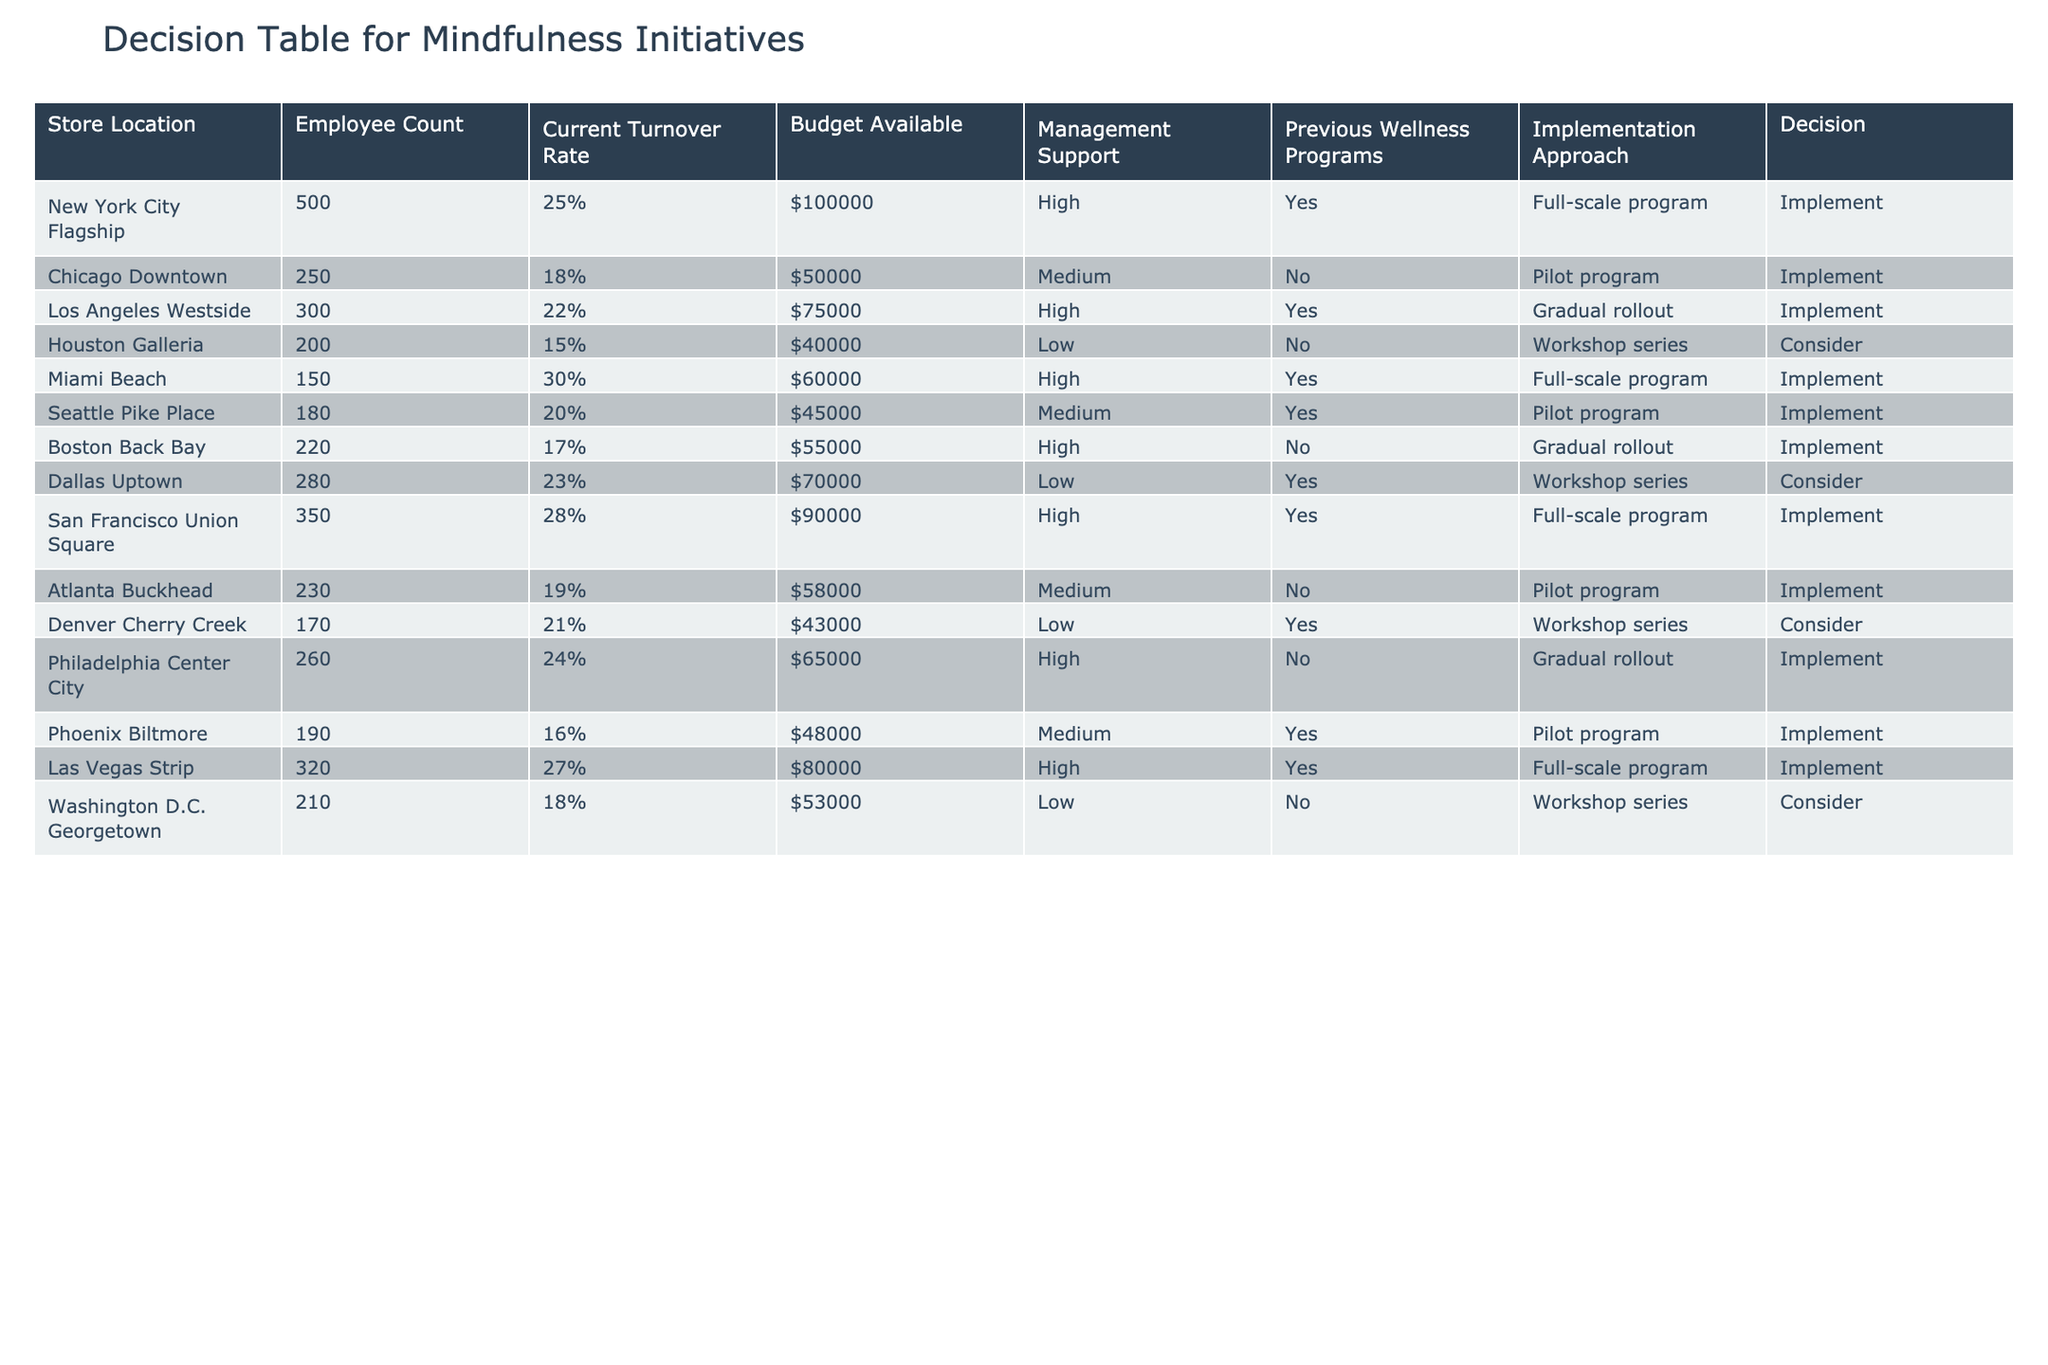What is the total employee count across all store locations? To find the total employee count, sum the Employee Count values from each row in the table: 500 + 250 + 300 + 200 + 150 + 180 + 220 + 280 + 350 + 230 + 170 + 260 + 190 + 320 + 210 = 3,060.
Answer: 3060 Which store location has the highest turnover rate? To find the highest turnover rate, compare the Current Turnover Rate values for each store. The maximum value is 30% from the Miami Beach location.
Answer: Miami Beach How many locations have implemented a full-scale program? Count the number of entries in the Decision column that state "Implement" and have "Full-scale program" in the Implementation Approach. These locations are New York City Flagship, Miami Beach, San Francisco Union Square, and Las Vegas Strip, giving a total of 4 locations.
Answer: 4 What is the average turnover rate of the stores with management support? First, identify the stores with High or Medium Management Support which are New York City Flagship, Los Angeles Westside, Miami Beach, Seattle Pike Place, Boston Back Bay, San Francisco Union Square, and Phoenix Biltmore. Their turnover rates are 25%, 22%, 30%, 20%, 17%, 28%, and 16%. The average is (25 + 22 + 30 + 20 + 17 + 28 + 16) / 7 = 20.14%.
Answer: 20.14% Is there a relationship between budget available and turnover rate for the stores implementing mindfulness initiatives? To analyze this, we look at the Budget Available and Current Turnover Rate for all stores marked as "Implement." Noticing varied budgets (ranging from $50,000 to $100,000) with turnover rates of 15%, 18%, 19%, 20%, 24%, 27%, and 30%, there doesn't appear to be a clear linear relationship, as higher budgets do not necessarily correlate with lower turnover rates.
Answer: No clear relationship How many stores considered the mindfulness initiatives instead of implementing them? Review the Decision column for "Consider." The stores that are marked as "Consider" are Houston Galleria, Dallas Uptown, Denver Cherry Creek, and Washington D.C. Georgetown, totaling to 4 stores that are in a consideration phase rather than implementation.
Answer: 4 What is the percentage of stores with previous wellness programs that are implementing mindfulness initiatives? Count the total stores with previous wellness programs (Yes): 5 (New York City Flagship, Los Angeles Westside, Miami Beach, San Francisco Union Square, and Phoenix Biltmore). Also, check how many of these are implementing (all 5). Hence, the percentage is (5/5) * 100 = 100%.
Answer: 100% Are all stores with low management support considering mindfulness initiatives? Check the Management Support column for "Low" and look at their respective decisions. The stores with low management support are Houston Galleria, Dallas Uptown, Denver Cherry Creek, and Washington D.C. Georgetown. Out of these, only Houston Galleria, Dallas Uptown, and Washington D.C. Georgetown are considering. Thus, the answer is no as Denver Cherry Creek has a different approach.
Answer: No 